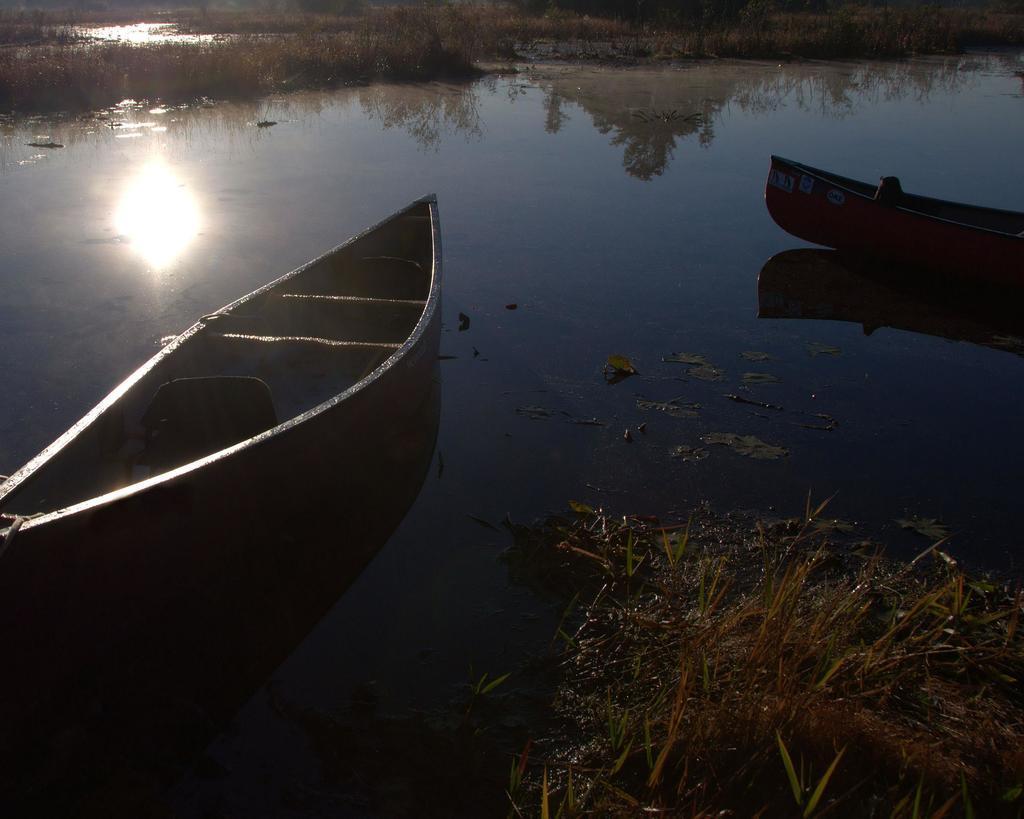Describe this image in one or two sentences. In the image we can see there are two boats in the water. Here we can see water and in the water we can see the reflection of the sun and plant. Here we can see the grass. 